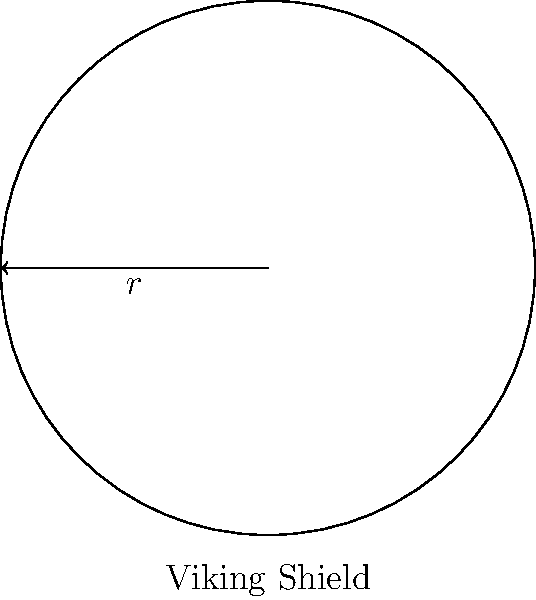In Norse sagas, Viking warriors were known for their circular shields. If a young Viking craftsman creates a shield with a radius of 50 cm, what is the area of the shield's surface? Round your answer to the nearest square centimeter. To find the area of a circular Viking shield, we'll use the formula for the area of a circle:

$$A = \pi r^2$$

Where:
$A$ = area of the circle
$\pi$ = pi (approximately 3.14159)
$r$ = radius of the circle

Given:
$r = 50$ cm

Step 1: Substitute the values into the formula:
$$A = \pi (50\text{ cm})^2$$

Step 2: Calculate the square of the radius:
$$A = \pi (2500\text{ cm}^2)$$

Step 3: Multiply by π:
$$A \approx 3.14159 \times 2500\text{ cm}^2 = 7853.975\text{ cm}^2$$

Step 4: Round to the nearest square centimeter:
$$A \approx 7854\text{ cm}^2$$

Therefore, the area of the Viking shield is approximately 7854 square centimeters.
Answer: $7854\text{ cm}^2$ 